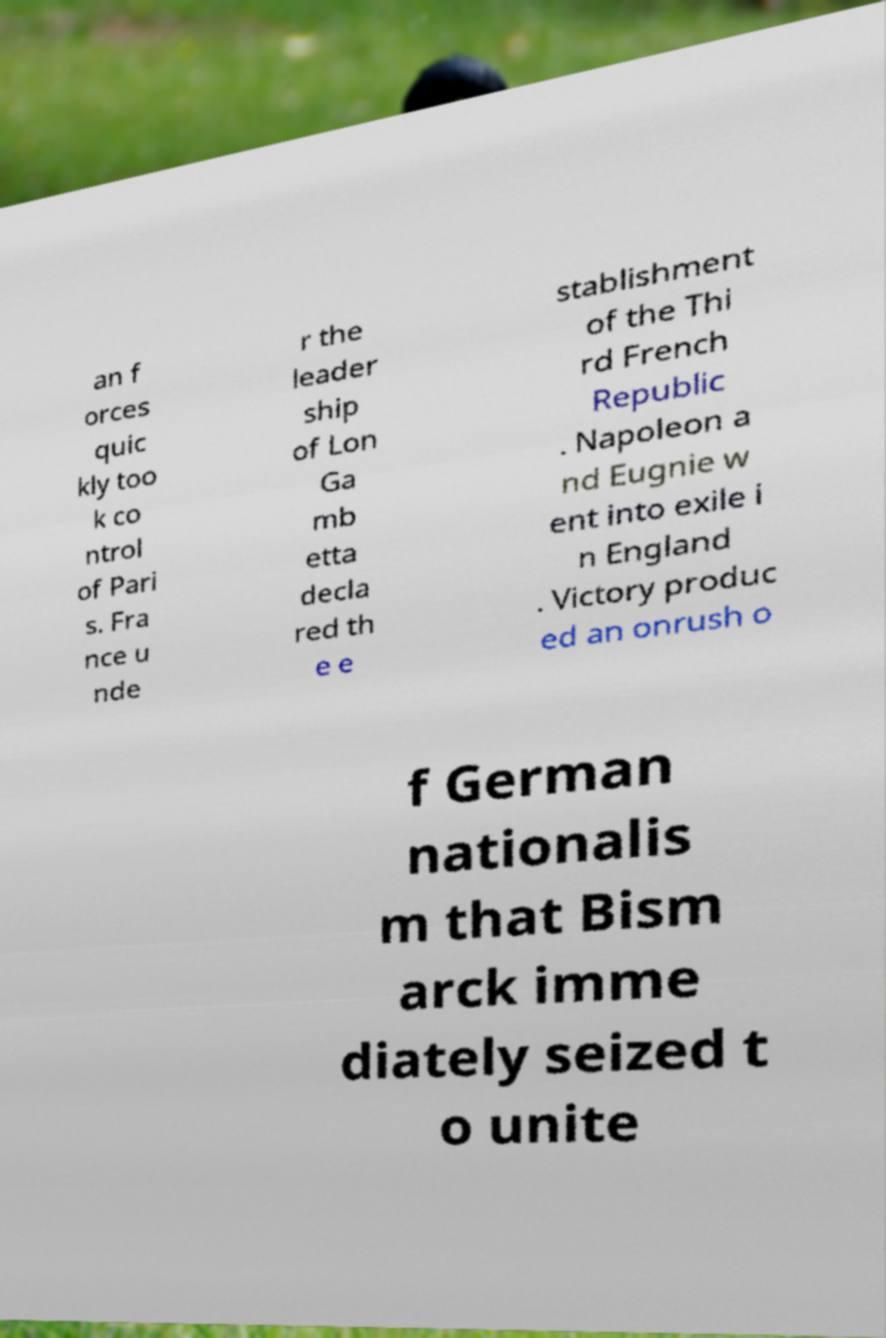Can you read and provide the text displayed in the image?This photo seems to have some interesting text. Can you extract and type it out for me? an f orces quic kly too k co ntrol of Pari s. Fra nce u nde r the leader ship of Lon Ga mb etta decla red th e e stablishment of the Thi rd French Republic . Napoleon a nd Eugnie w ent into exile i n England . Victory produc ed an onrush o f German nationalis m that Bism arck imme diately seized t o unite 